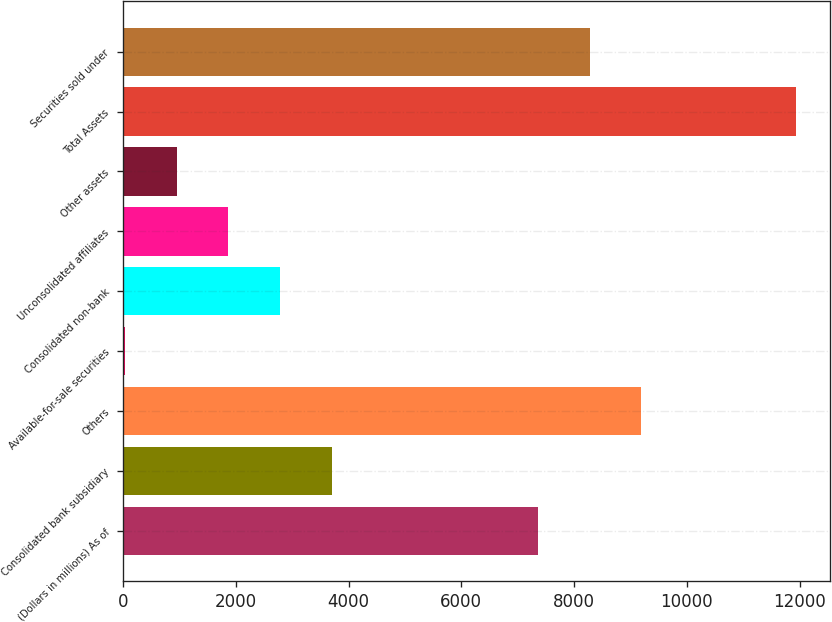<chart> <loc_0><loc_0><loc_500><loc_500><bar_chart><fcel>(Dollars in millions) As of<fcel>Consolidated bank subsidiary<fcel>Others<fcel>Available-for-sale securities<fcel>Consolidated non-bank<fcel>Unconsolidated affiliates<fcel>Other assets<fcel>Total Assets<fcel>Securities sold under<nl><fcel>7358.6<fcel>3697.8<fcel>9189<fcel>37<fcel>2782.6<fcel>1867.4<fcel>952.2<fcel>11934.6<fcel>8273.8<nl></chart> 